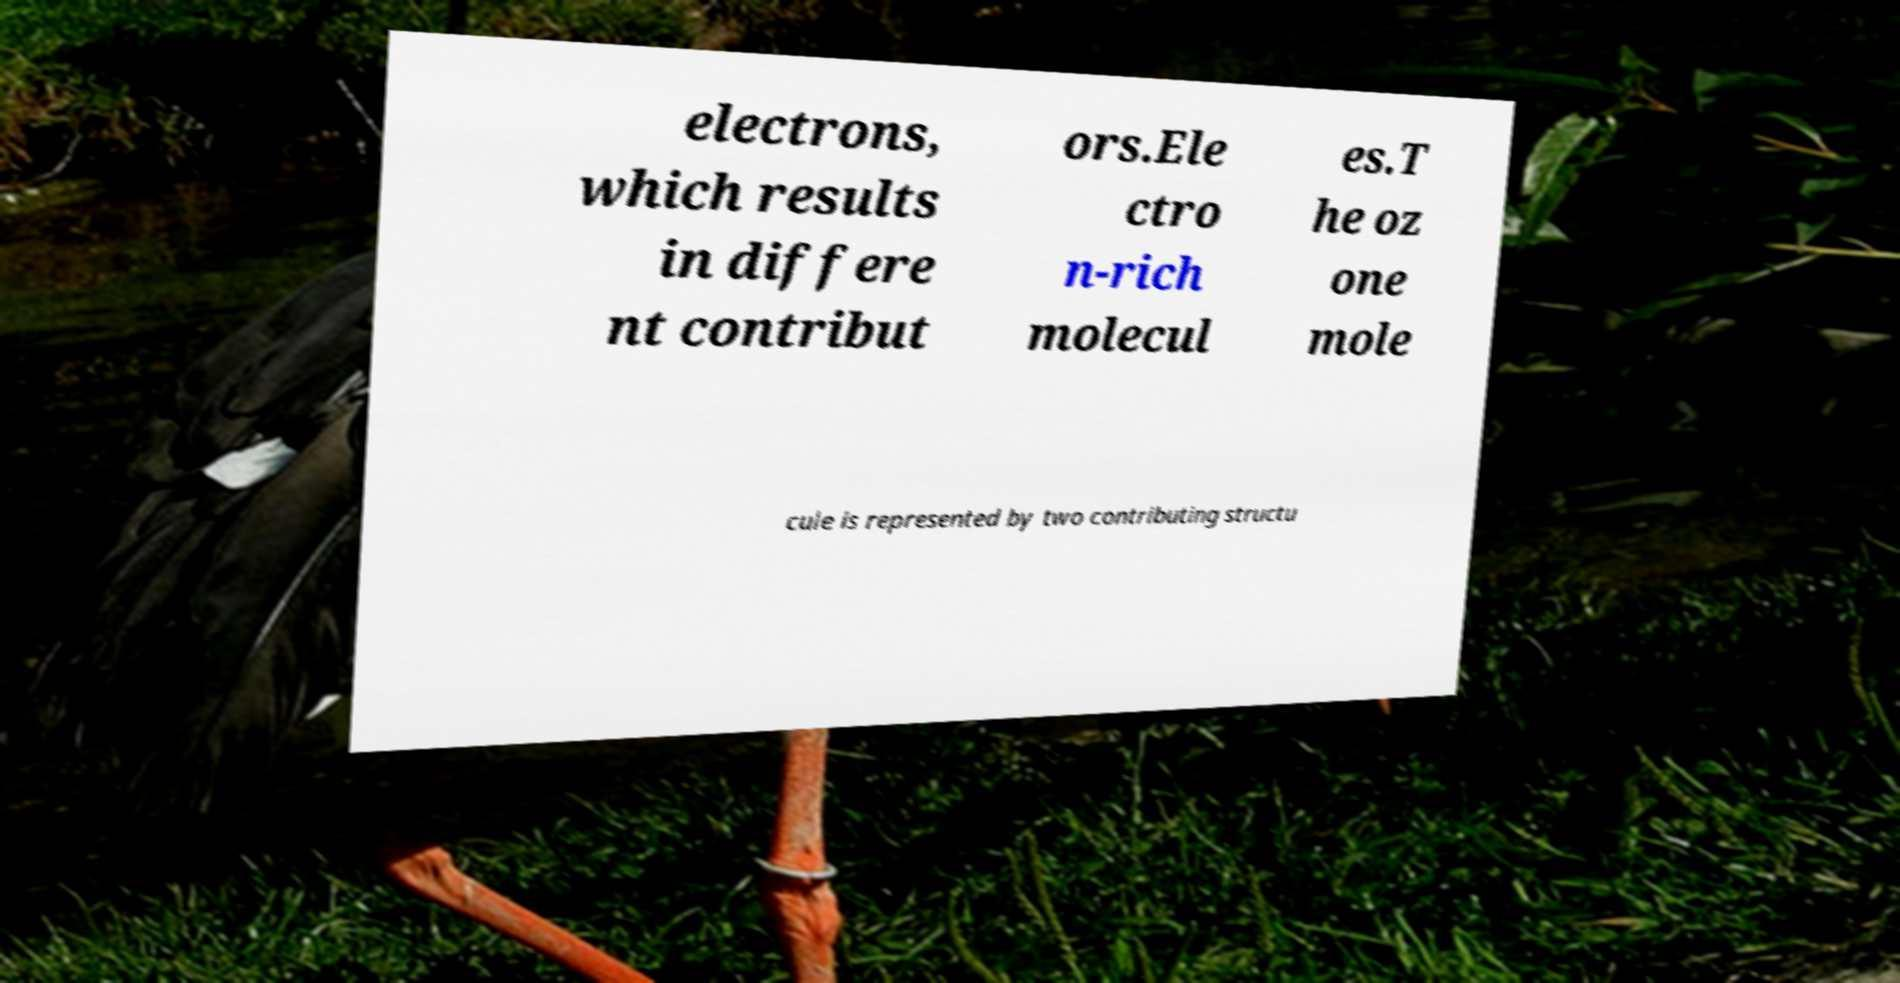Could you assist in decoding the text presented in this image and type it out clearly? electrons, which results in differe nt contribut ors.Ele ctro n-rich molecul es.T he oz one mole cule is represented by two contributing structu 